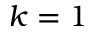Convert formula to latex. <formula><loc_0><loc_0><loc_500><loc_500>k = 1</formula> 